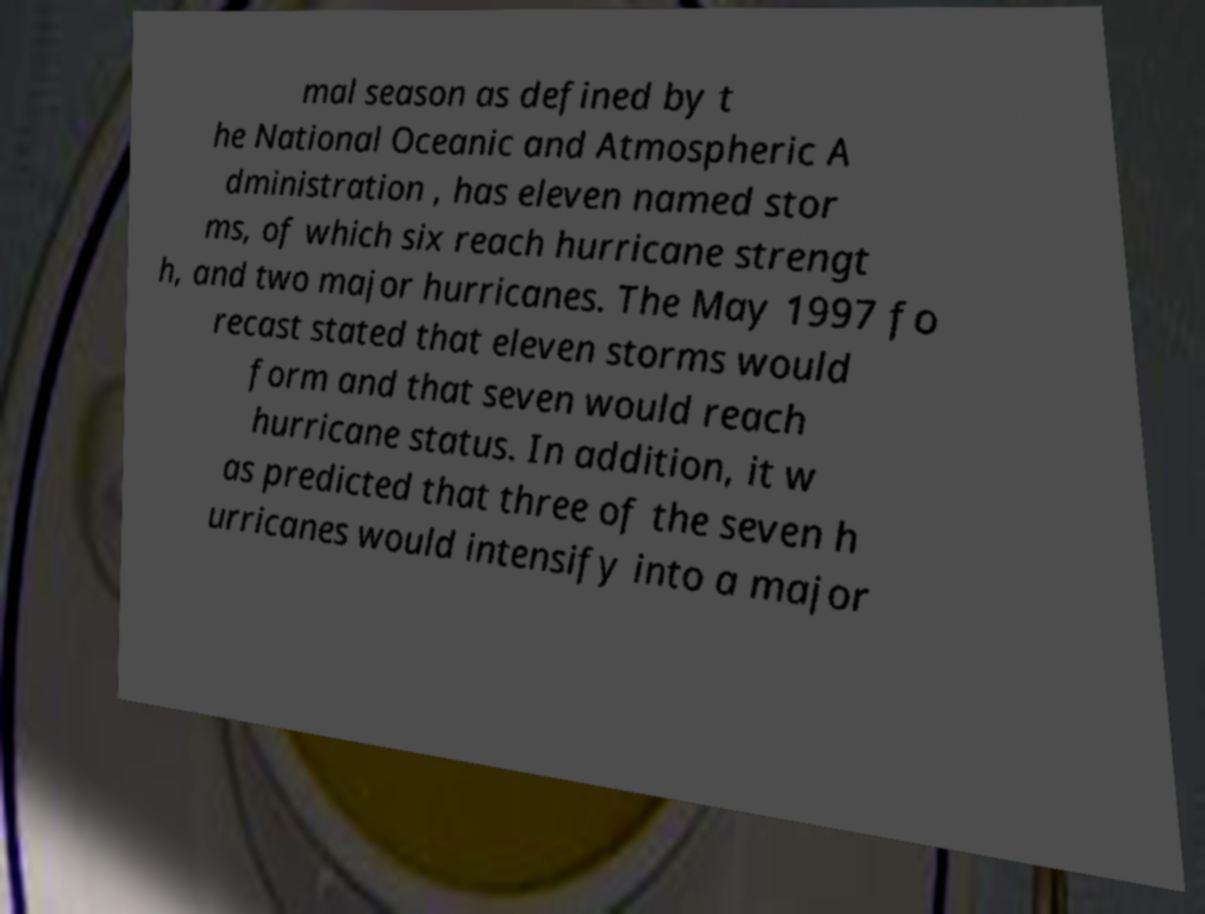Can you read and provide the text displayed in the image?This photo seems to have some interesting text. Can you extract and type it out for me? mal season as defined by t he National Oceanic and Atmospheric A dministration , has eleven named stor ms, of which six reach hurricane strengt h, and two major hurricanes. The May 1997 fo recast stated that eleven storms would form and that seven would reach hurricane status. In addition, it w as predicted that three of the seven h urricanes would intensify into a major 